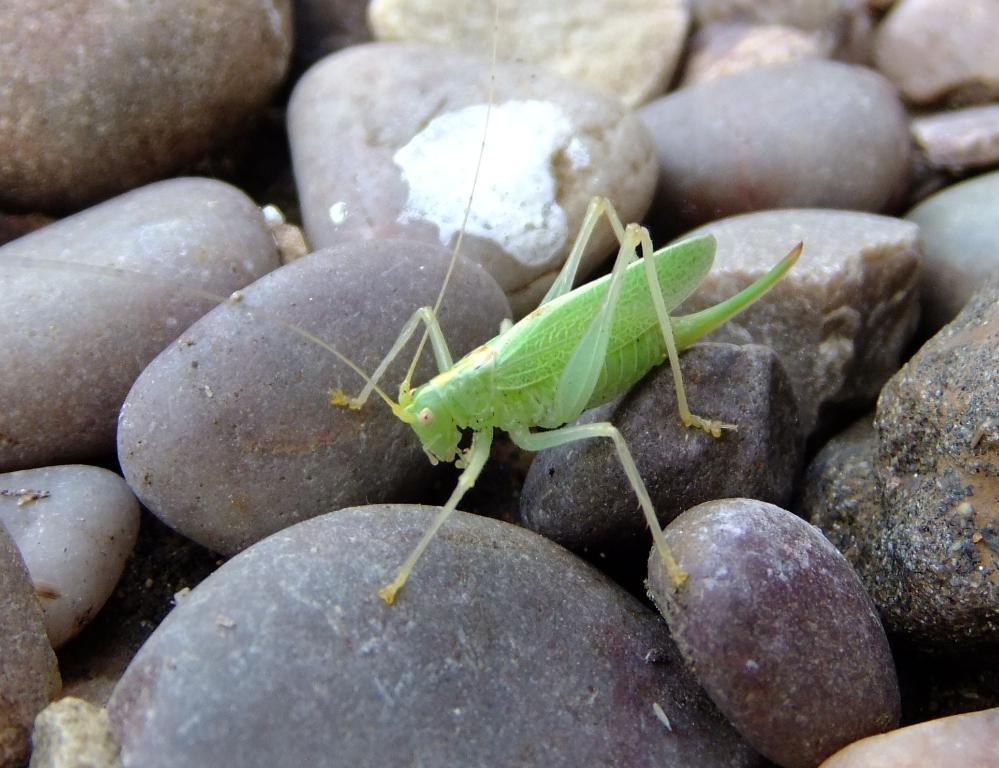What type of creature is present in the image? There is an insect in the image. Can you describe the insect's appearance? The insect resembles a grasshopper and is green in color. What else can be seen at the bottom of the image? There are stones visible at the bottom of the image. How many screws can be seen in the image? There are no screws present in the image. What type of bird is sitting on the grasshopper in the image? There is no bird present in the image, and the grasshopper is not interacting with any other creature. 